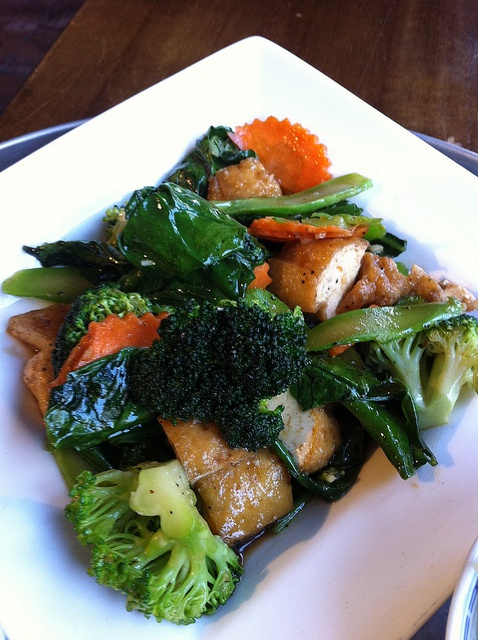Describe the objects in this image and their specific colors. I can see bowl in white, black, darkgray, and darkgreen tones, broccoli in black, teal, and darkgreen tones, broccoli in black, darkgreen, olive, and green tones, broccoli in black, darkgreen, olive, and green tones, and carrot in black, red, brown, and lavender tones in this image. 